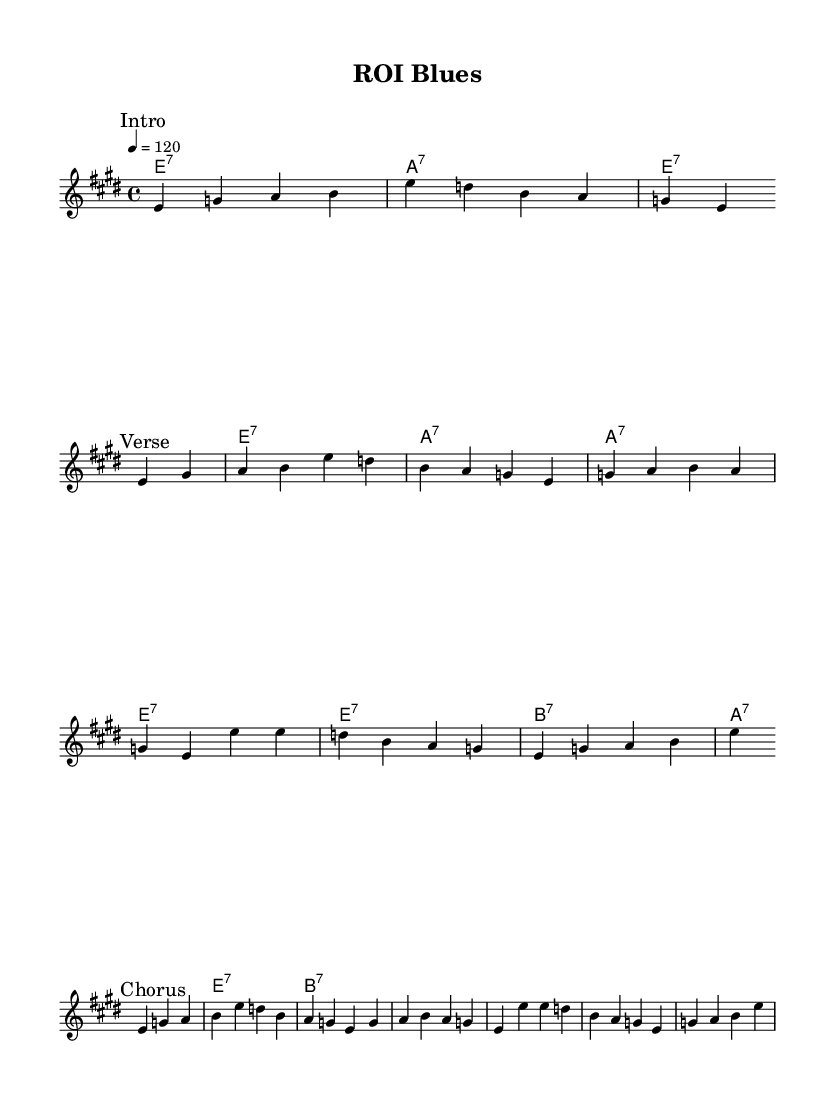What is the key signature of this music? The key signature indicates that the piece is in E major, which has four sharps. This can be determined by the key signature notation at the beginning of the staff.
Answer: E major What is the time signature of this music? The time signature is 4/4, indicated at the start of the sheet music. This means there are four beats per measure and the quarter note receives one beat.
Answer: 4/4 What is the tempo marking for this piece? The tempo marking is indicated as "4 = 120", which means the piece should be played at a metronome speed of 120 beats per minute. This is found in the tempo indication at the beginning of the score.
Answer: 120 How many verses are included in this music? The music features one verse, which can be identified by the lyric section labeled "Verse" and is accompanied by the melody.
Answer: One What is the primary theme of the lyrics in this piece? The primary theme revolves around business success and achieving goals, as evidenced by lyrics discussing ROI, target achievements, and the hustle of brand managers. This reflects the electric blues style adapted to a business context.
Answer: Business success What chord is used most frequently throughout the piece? The E7 chord is the most frequently used chord, appearing consistently in the chord progression during the verses and chorus. This can be derived from the repetition of the E7 chord labeled in the chord names.
Answer: E7 What is the significance of the chorus in relation to the verses? The chorus emphasizes the commitment to success and the acknowledgment of effort, encapsulating the overall message of resilience and determination as portrayed in the verses. The lyrics denote a reflection of the ongoing journey toward business goals.
Answer: Commitment to success 